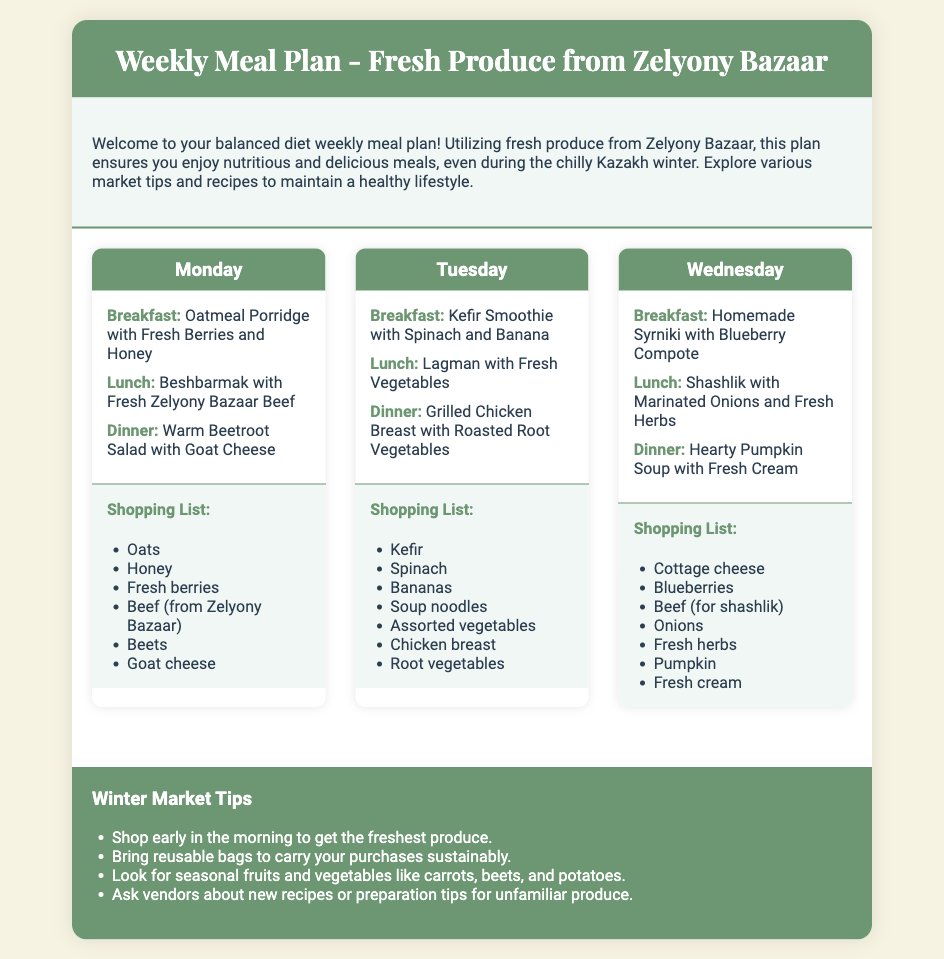What is the title of the meal plan? The title of the meal plan is clearly stated at the top of the document.
Answer: Weekly Meal Plan - Fresh Produce from Zelyony Bazaar Which day includes Shashlik in the lunch meal? The document details the meals for each day, and Shashlik is listed under Wednesday's lunch.
Answer: Wednesday How many meals are listed for Tuesday? Each day of the meal plan features three meals, and Tuesday is no exception.
Answer: Three What is suggested for breakfast on Monday? The document specifies breakfast options for every day, with Monday's option being highlighted.
Answer: Oatmeal Porridge with Fresh Berries and Honey What are the tips for shopping at winter markets? The document lists several practical tips under a specific section dedicated to winter market advice.
Answer: Shop early in the morning to get the freshest produce What type of cheese is used in the dinner meal on Monday? The document describes the meals of the day, particularly focusing on cheese details for the warm beetroot salad.
Answer: Goat cheese What fruit is included in the Kefir Smoothie for Tuesday's breakfast? The document lists the ingredients for Tuesday's breakfast, specifically naming the fruit used.
Answer: Banana Which meal features roasted root vegetables? The document includes detailed information about the meals for Tuesday, mentioning the dinner specifically.
Answer: Dinner 